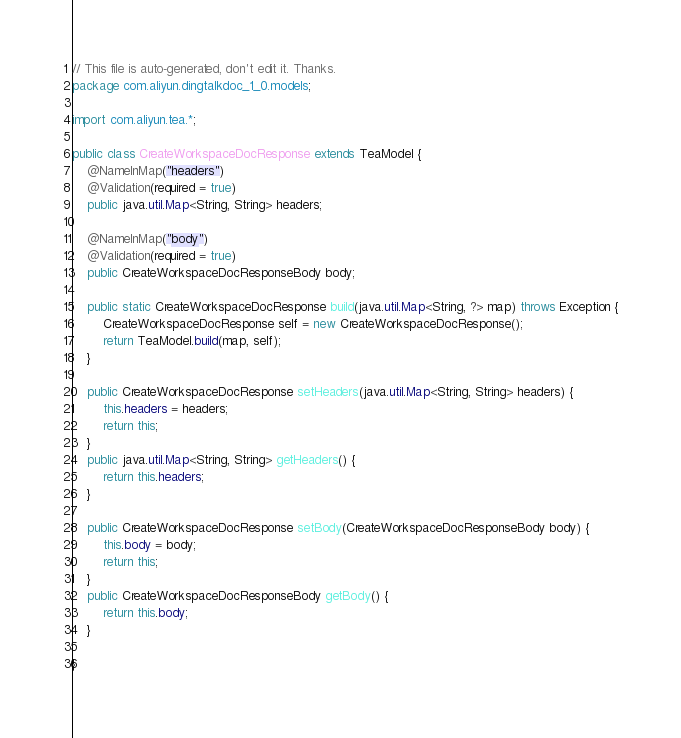Convert code to text. <code><loc_0><loc_0><loc_500><loc_500><_Java_>// This file is auto-generated, don't edit it. Thanks.
package com.aliyun.dingtalkdoc_1_0.models;

import com.aliyun.tea.*;

public class CreateWorkspaceDocResponse extends TeaModel {
    @NameInMap("headers")
    @Validation(required = true)
    public java.util.Map<String, String> headers;

    @NameInMap("body")
    @Validation(required = true)
    public CreateWorkspaceDocResponseBody body;

    public static CreateWorkspaceDocResponse build(java.util.Map<String, ?> map) throws Exception {
        CreateWorkspaceDocResponse self = new CreateWorkspaceDocResponse();
        return TeaModel.build(map, self);
    }

    public CreateWorkspaceDocResponse setHeaders(java.util.Map<String, String> headers) {
        this.headers = headers;
        return this;
    }
    public java.util.Map<String, String> getHeaders() {
        return this.headers;
    }

    public CreateWorkspaceDocResponse setBody(CreateWorkspaceDocResponseBody body) {
        this.body = body;
        return this;
    }
    public CreateWorkspaceDocResponseBody getBody() {
        return this.body;
    }

}
</code> 